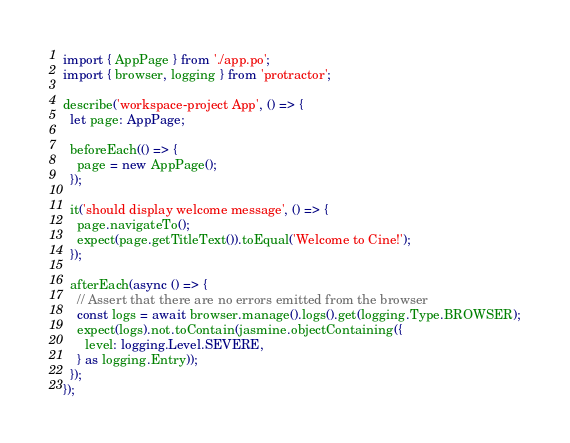<code> <loc_0><loc_0><loc_500><loc_500><_TypeScript_>import { AppPage } from './app.po';
import { browser, logging } from 'protractor';

describe('workspace-project App', () => {
  let page: AppPage;

  beforeEach(() => {
    page = new AppPage();
  });

  it('should display welcome message', () => {
    page.navigateTo();
    expect(page.getTitleText()).toEqual('Welcome to Cine!');
  });

  afterEach(async () => {
    // Assert that there are no errors emitted from the browser
    const logs = await browser.manage().logs().get(logging.Type.BROWSER);
    expect(logs).not.toContain(jasmine.objectContaining({
      level: logging.Level.SEVERE,
    } as logging.Entry));
  });
});
</code> 